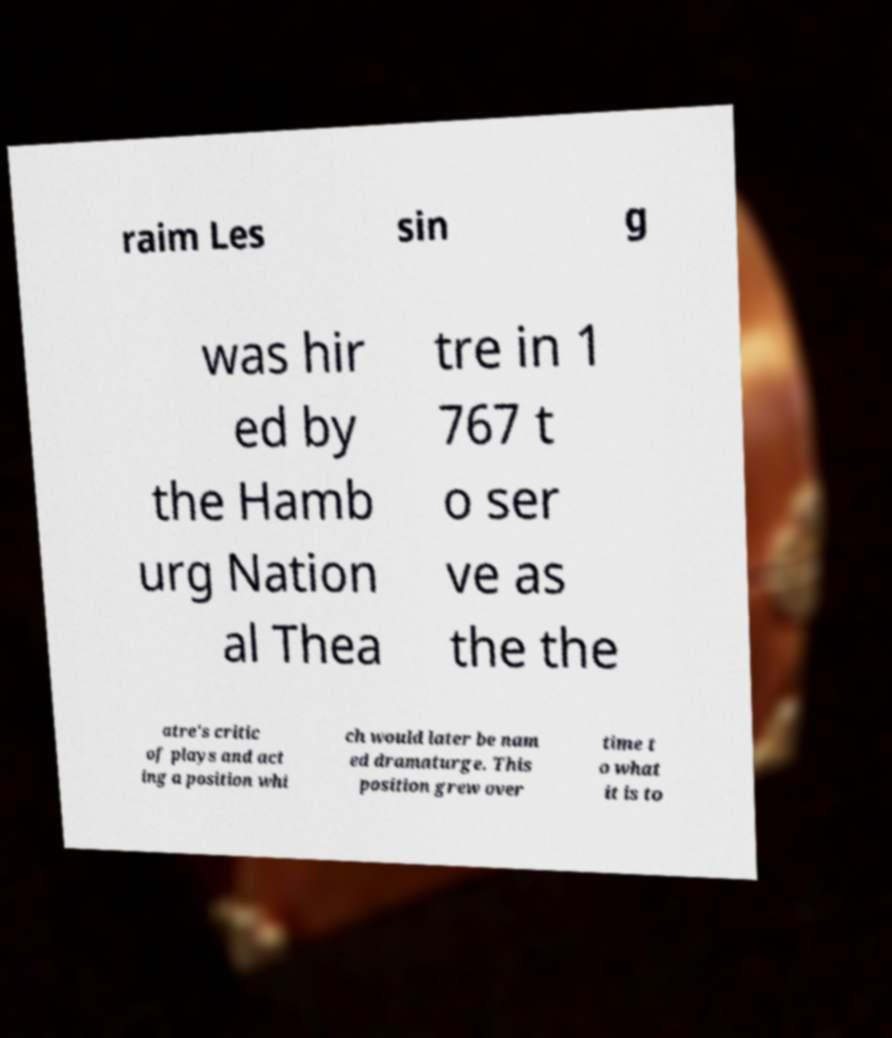Please identify and transcribe the text found in this image. raim Les sin g was hir ed by the Hamb urg Nation al Thea tre in 1 767 t o ser ve as the the atre's critic of plays and act ing a position whi ch would later be nam ed dramaturge. This position grew over time t o what it is to 